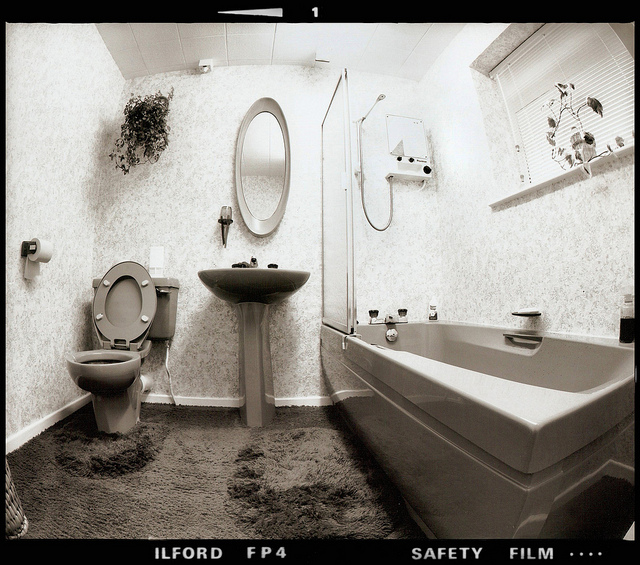Please extract the text content from this image. ILFORD F P 4 SAFETY FILM 1 